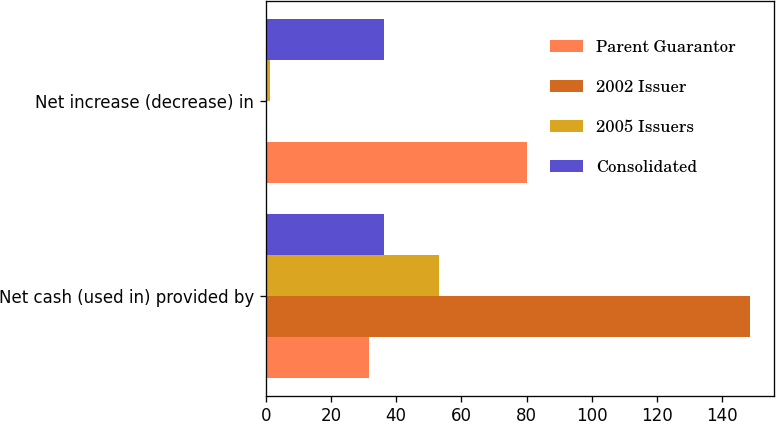Convert chart. <chart><loc_0><loc_0><loc_500><loc_500><stacked_bar_chart><ecel><fcel>Net cash (used in) provided by<fcel>Net increase (decrease) in<nl><fcel>Parent Guarantor<fcel>31.6<fcel>80.1<nl><fcel>2002 Issuer<fcel>148.5<fcel>0.5<nl><fcel>2005 Issuers<fcel>53.2<fcel>1.3<nl><fcel>Consolidated<fcel>36.2<fcel>36.2<nl></chart> 